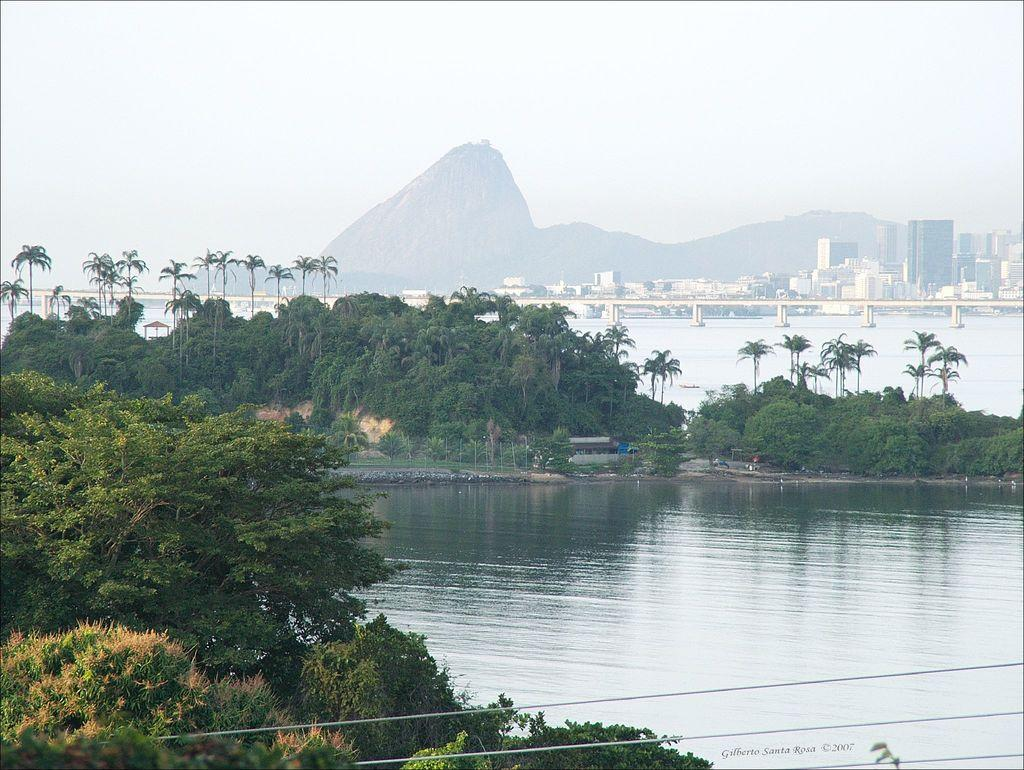What is the primary element in the image? There is water in the image. What can be seen near the water? There are many trees near the water. What structures are visible in the background? There is a bridge and multiple buildings in the background. What type of natural landscape is visible in the background? There are mountains in the background. What else can be seen in the background? The sky is visible in the background. What type of paper is being used by the bat in the image? There is no bat or paper present in the image. 